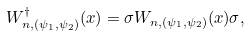<formula> <loc_0><loc_0><loc_500><loc_500>W _ { n , ( \psi _ { 1 } , \psi _ { 2 } ) } ^ { \dagger } ( x ) = \sigma W _ { n , ( \psi _ { 1 } , \psi _ { 2 } ) } ( x ) \sigma ,</formula> 